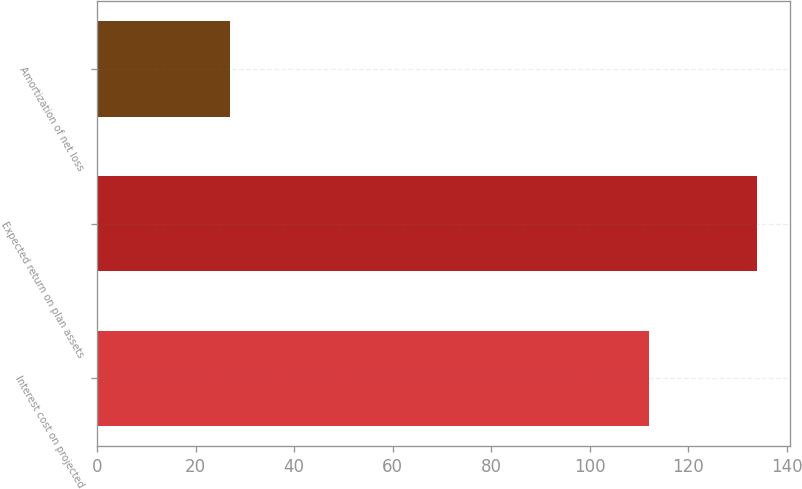<chart> <loc_0><loc_0><loc_500><loc_500><bar_chart><fcel>Interest cost on projected<fcel>Expected return on plan assets<fcel>Amortization of net loss<nl><fcel>112<fcel>134<fcel>27<nl></chart> 